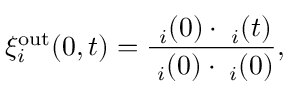<formula> <loc_0><loc_0><loc_500><loc_500>\xi _ { i } ^ { o u t } ( 0 , t ) = \frac { { \ell } _ { i } ( 0 ) \cdot { \ell } _ { i } ( t ) } { { \ell } _ { i } ( 0 ) \cdot { \ell } _ { i } ( 0 ) } ,</formula> 